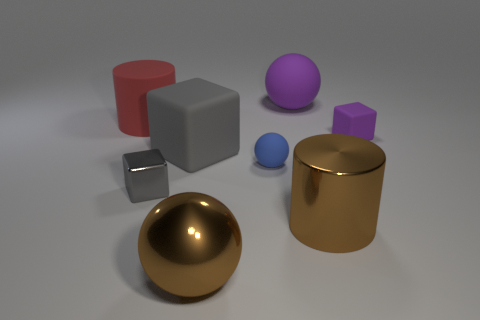What materials appear to be depicted in the objects shown? The objects appear to be rendered with materials that imitate metal and plastic. The golden sphere and cylinder have a metallic sheen, while the cube, cylinder, and spheres have a matte finish that suggests a plastic quality. Are there any patterns or textures on any of the objects? All the objects in the image display a smooth surface without any visible patterns or textures, emphasizing their simple geometrical shapes. 